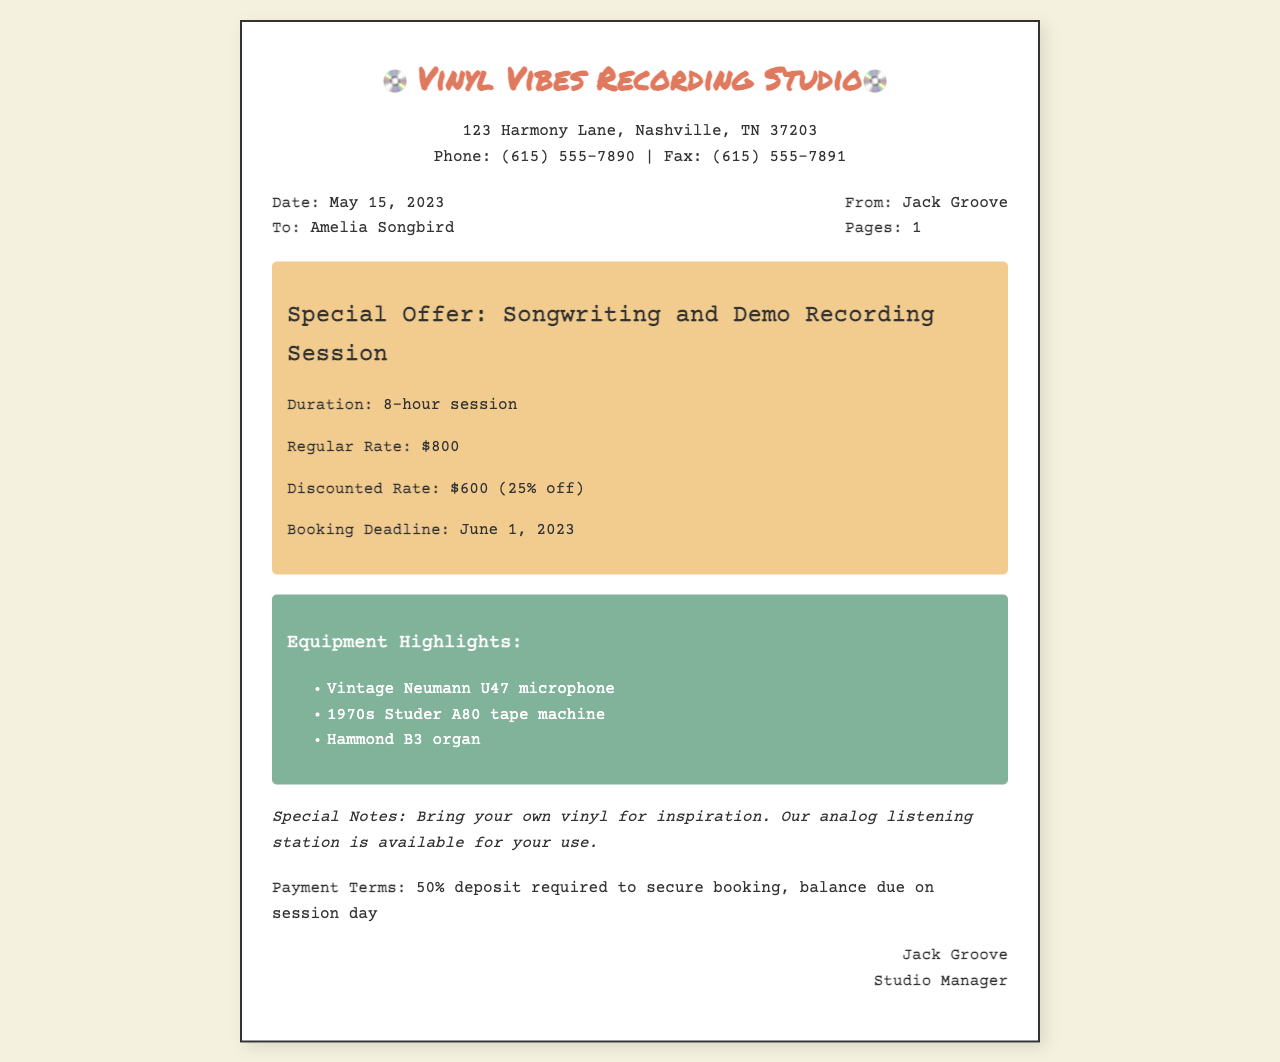what is the name of the recording studio? The name of the studio is mentioned prominently at the top of the document.
Answer: Vinyl Vibes Recording Studio who is the studio manager? The studio manager is identified at the bottom of the document where the signature is located.
Answer: Jack Groove what is the discounted rate for the session? The discounted rate is highlighted in the offer details section of the document.
Answer: $600 when is the booking deadline? The booking deadline is specified in the offer details section.
Answer: June 1, 2023 what is the duration of the songwriting session? The duration is mentioned directly in the offer details of the document.
Answer: 8-hour session how much is the regular rate for the session? The regular rate is stated in the offer details section of the document.
Answer: $800 what percentage discount is being offered? The percentage discount can be inferred from the difference between the regular rate and the discounted rate.
Answer: 25% what is required to secure the booking? The payment terms section outlines what is needed to secure the booking.
Answer: 50% deposit what special equipment is highlighted in the document? The equipment highlights section lists specific items available for the session.
Answer: Vintage Neumann U47 microphone, 1970s Studer A80 tape machine, Hammond B3 organ 